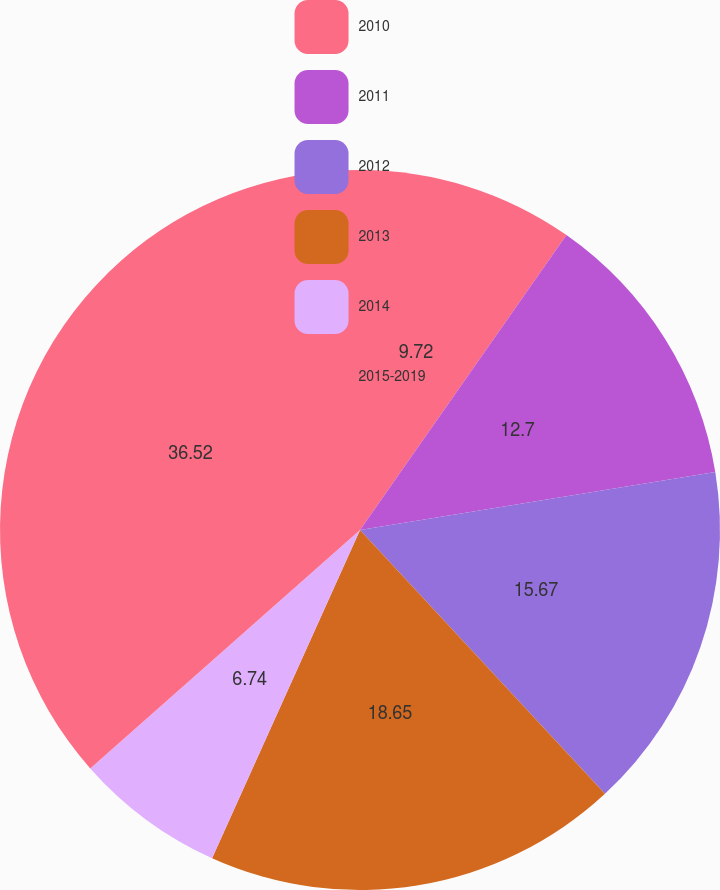<chart> <loc_0><loc_0><loc_500><loc_500><pie_chart><fcel>2010<fcel>2011<fcel>2012<fcel>2013<fcel>2014<fcel>2015-2019<nl><fcel>9.72%<fcel>12.7%<fcel>15.67%<fcel>18.65%<fcel>6.74%<fcel>36.52%<nl></chart> 